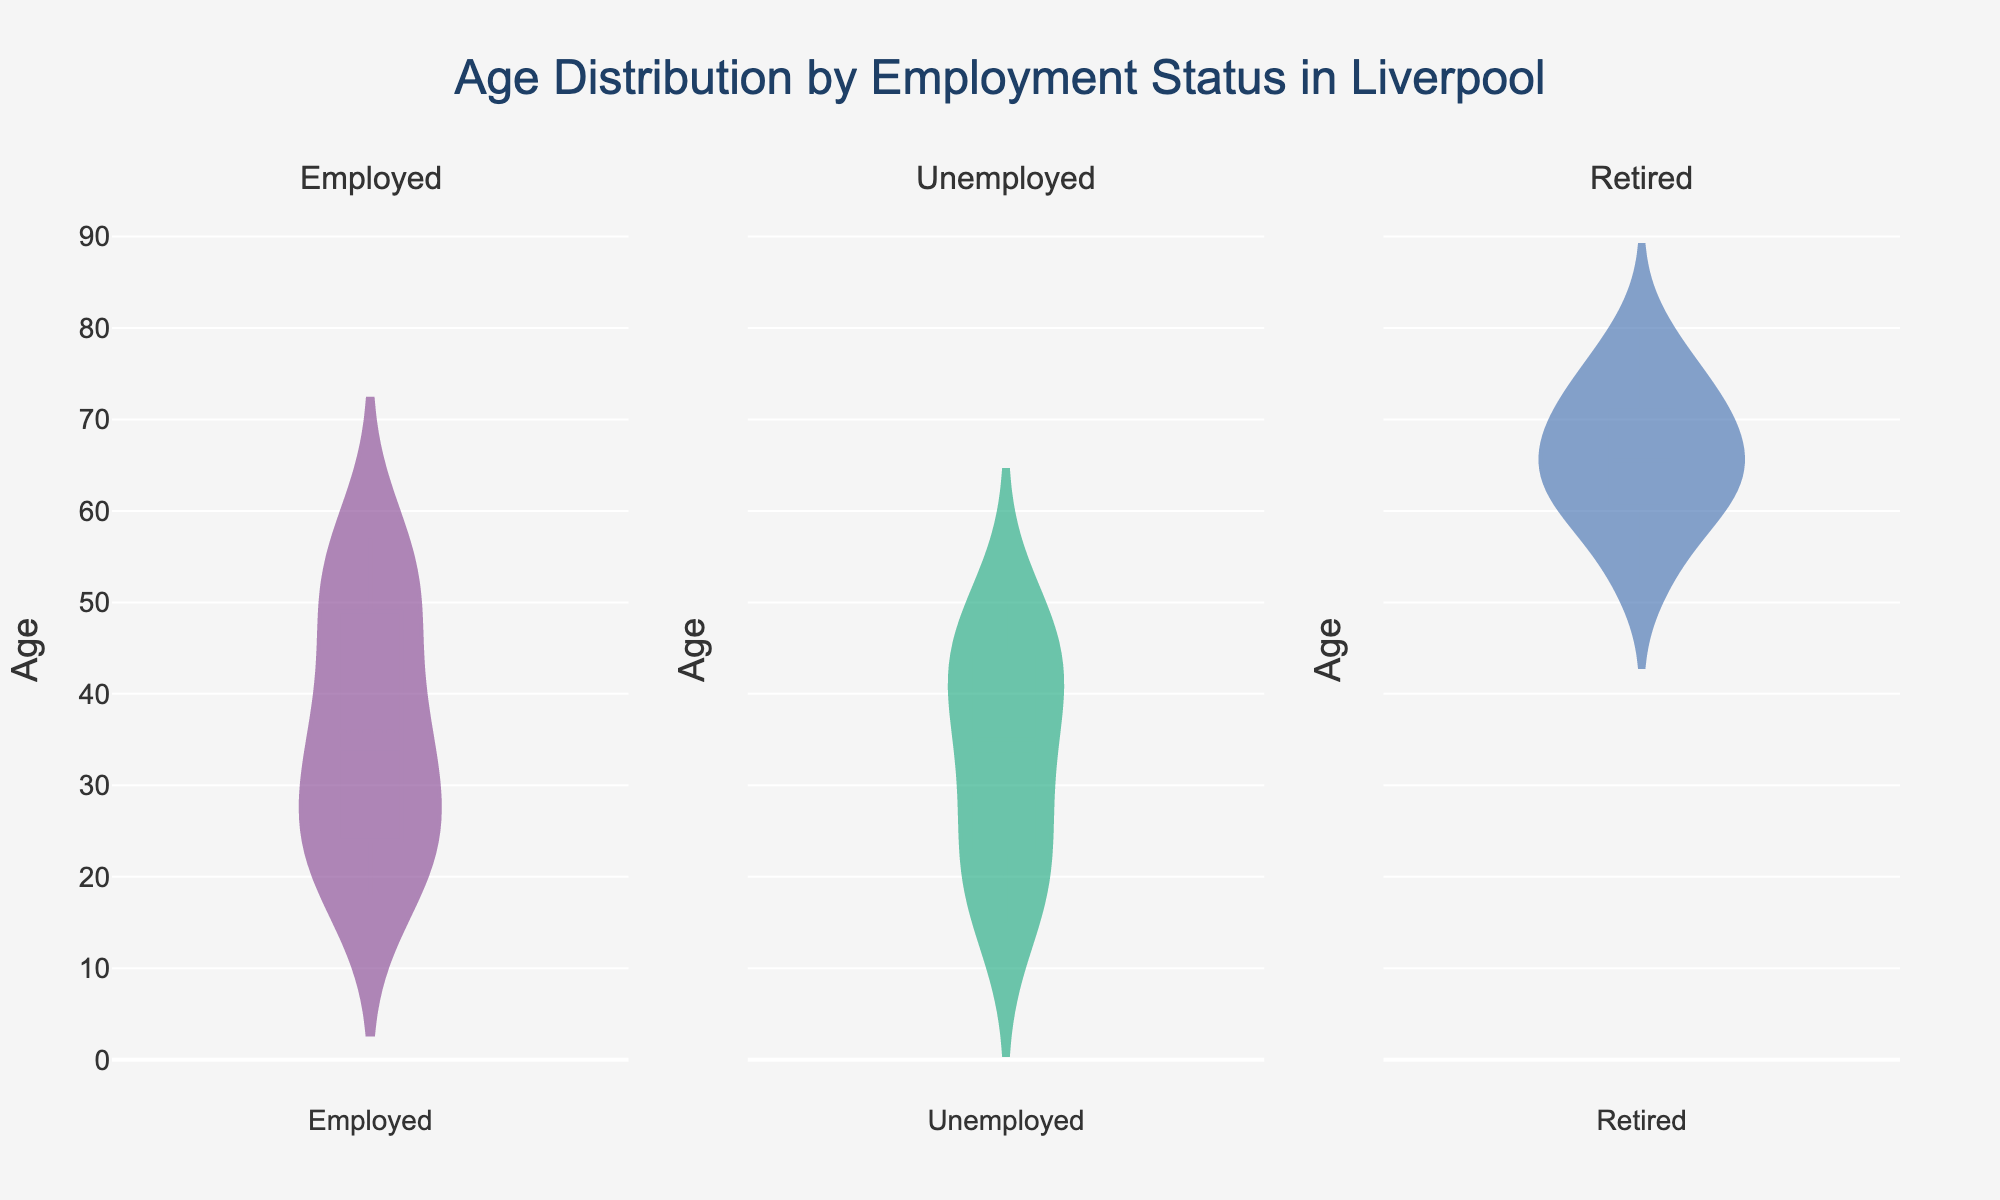What is the title of the figure? The title is usually displayed prominently at the top of the figure. It provides a summary of what the figure is about. In this case, you can see the title in large, bold text.
Answer: Age Distribution by Employment Status in Liverpool Which employment status category has the youngest individuals? By looking at the range of ages represented in each subplot, you can see where the minimum age data point appears. The subplot with the lowest minimum age represents the category with the youngest individuals.
Answer: Unemployed How many employment status categories are displayed in the figure? The figure shows subplots for different employment status categories, each clearly labeled as a subplot title. Count these titles to determine the number of categories.
Answer: Four Which employment status category shows the widest spread of ages? Examine the range from the minimum to maximum ages for each violin plot. The category with the greatest spread from top to bottom represents the widest age spread.
Answer: Retired What is the median age for the employed category? In a violin plot, the median is shown by the horizontal line within the “box” in the middle of the plot. Locate this line within the employed subplot.
Answer: Approximately 35-37 Which employment status category has the most concentrated age distribution? Look for the violin plot that is the narrowest around its median. This indicates a smaller spread and thus a more concentrated distribution.
Answer: Retired What is the common age range among employed individuals? Assess the range covered by the shape of the employed violin plot, from its lowest point to its highest point.
Answer: Approximately 20-57 Which category has the oldest individuals? Identify the maximum age value by looking at the highest point of the data distribution in each subplot. The highest point will indicate the oldest individuals.
Answer: Retired Is there an overlapping age range between unemployed and employed individuals? Compare the ranges of ages in the violin plots for employed and unemployed individuals. If their ranges intersect, then there is an overlap.
Answer: Yes Between the employed and unemployed categories, which has a lower median age? Compare the median lines of both subplots. The one that is lower in the vertical axis represents a lower median age.
Answer: Unemployed 